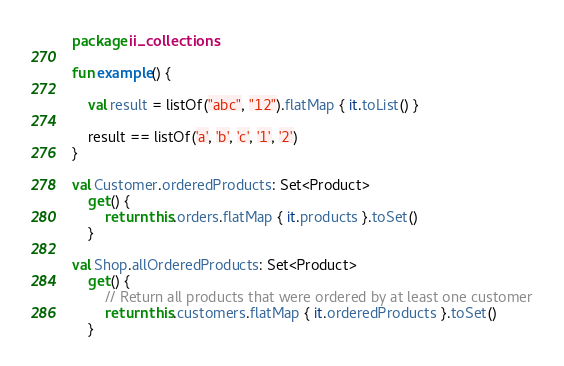<code> <loc_0><loc_0><loc_500><loc_500><_Kotlin_>package ii_collections

fun example() {

    val result = listOf("abc", "12").flatMap { it.toList() }

    result == listOf('a', 'b', 'c', '1', '2')
}

val Customer.orderedProducts: Set<Product>
    get() {
        return this.orders.flatMap { it.products }.toSet()
    }

val Shop.allOrderedProducts: Set<Product>
    get() {
        // Return all products that were ordered by at least one customer
        return this.customers.flatMap { it.orderedProducts }.toSet()
    }
</code> 